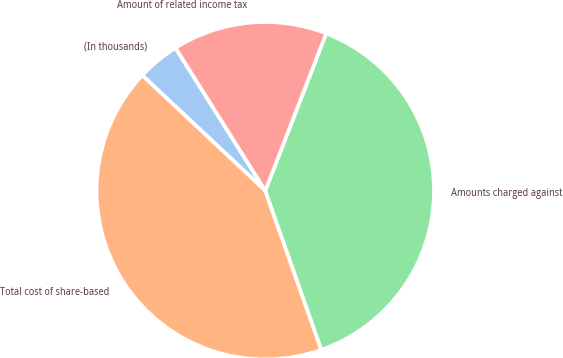Convert chart to OTSL. <chart><loc_0><loc_0><loc_500><loc_500><pie_chart><fcel>(In thousands)<fcel>Total cost of share-based<fcel>Amounts charged against<fcel>Amount of related income tax<nl><fcel>4.08%<fcel>42.38%<fcel>38.72%<fcel>14.81%<nl></chart> 